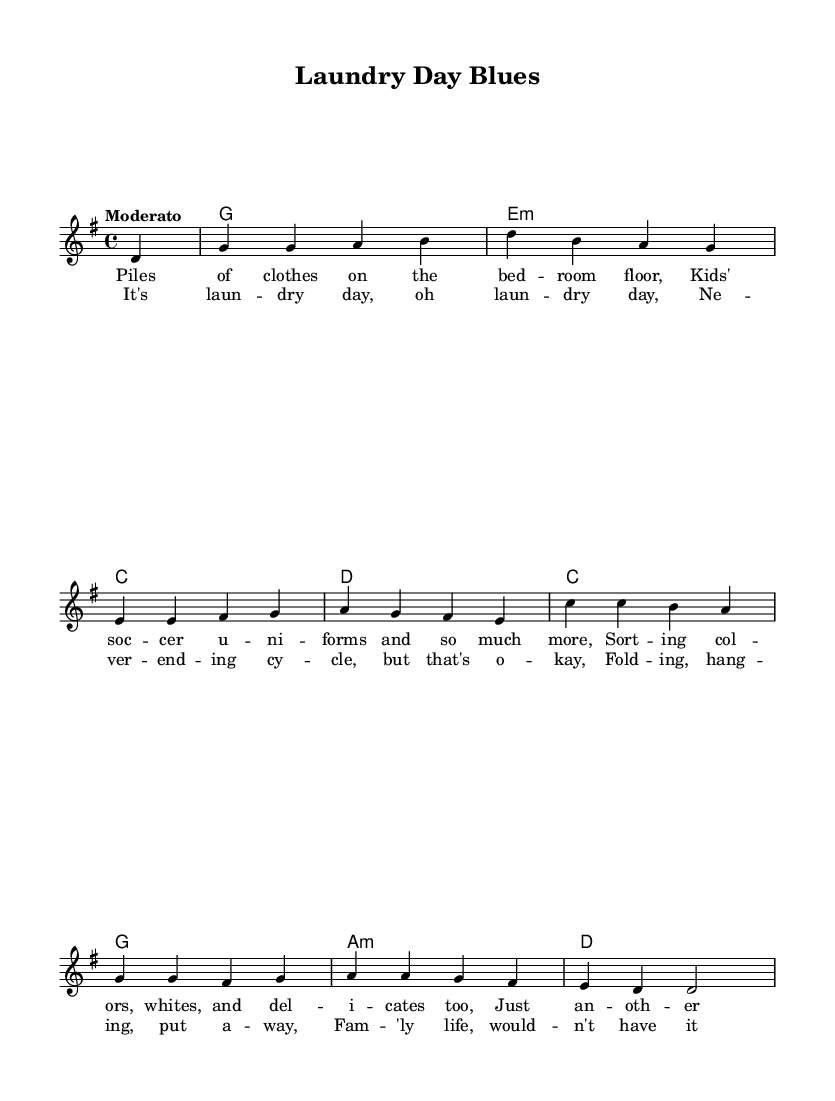What is the key signature of this music? The key signature indicated at the beginning of the score shows one sharp, which corresponds to the key of G major.
Answer: G major What is the time signature of this music? The time signature shown at the beginning of the score is 4 over 4, which means there are four beats per measure and the quarter note gets one beat.
Answer: 4/4 What is the tempo marking of the piece? The tempo marking written in the score is "Moderato," which indicates a moderate pace for the performance of the piece.
Answer: Moderato How many measures are in the verse? The verse section is comprised of four lines of lyrics; each line corresponds to one measure, totaling four measures in the verse.
Answer: 4 Which chord follows the first measure? The chord indicated after the first measure is G major, as shown in the harmonies section of the score.
Answer: G Describe the thematic content of the lyrics. The lyrics describe the relatable and everyday family experience of doing laundry, highlighting the mundane but frequent tasks that come with family life.
Answer: Family life What is the overall mood of the chorus based on the lyrics? The chorus conveys a sense of acceptance and lightheartedness regarding the never-ending cycle of chores, suggesting a positive outlook on family responsibilities.
Answer: Positive 